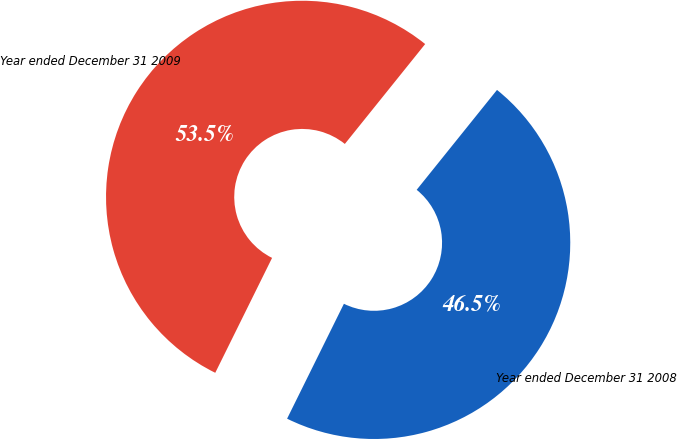Convert chart. <chart><loc_0><loc_0><loc_500><loc_500><pie_chart><fcel>Year ended December 31 2008<fcel>Year ended December 31 2009<nl><fcel>46.53%<fcel>53.47%<nl></chart> 